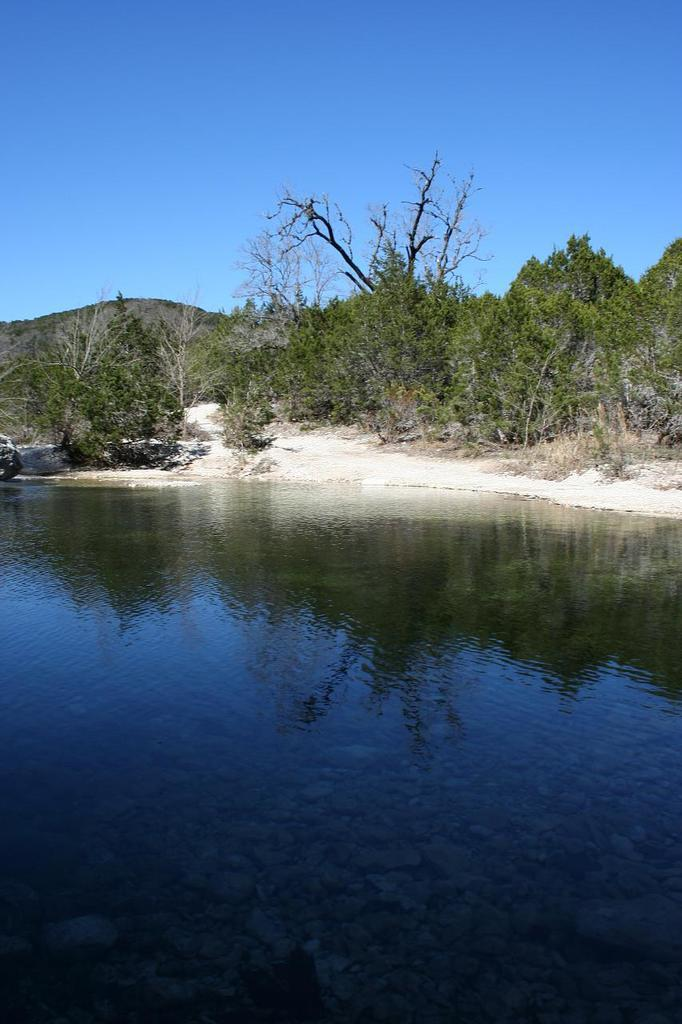What is one of the natural elements present in the image? There is water in the image. What type of vegetation can be seen in the image? There are trees and plants in the image. What type of terrain is visible in the image? There is sand and a hill in the image. What part of the natural environment is visible in the image? The sky is visible in the image. What type of pie is being served on the hill in the image? There is no pie present in the image; it features natural elements such as water, trees, plants, sand, and a hill. Can you tell me how many girls are visible in the image? There are no girls present in the image; it focuses on natural elements and the sky. 